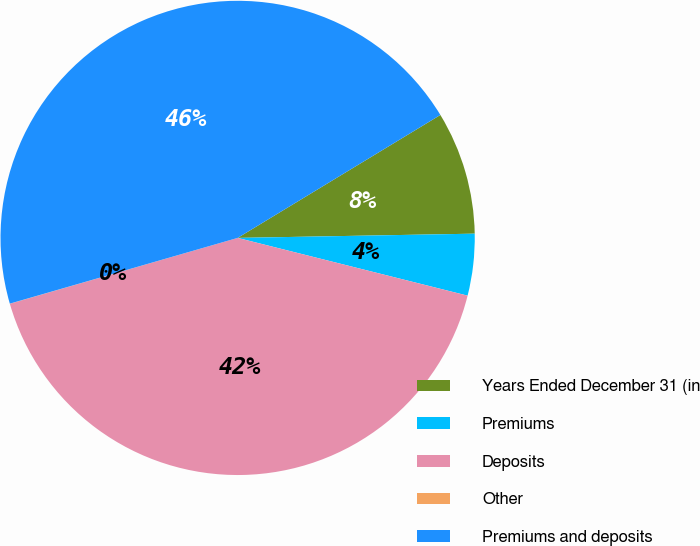<chart> <loc_0><loc_0><loc_500><loc_500><pie_chart><fcel>Years Ended December 31 (in<fcel>Premiums<fcel>Deposits<fcel>Other<fcel>Premiums and deposits<nl><fcel>8.39%<fcel>4.2%<fcel>41.6%<fcel>0.01%<fcel>45.79%<nl></chart> 